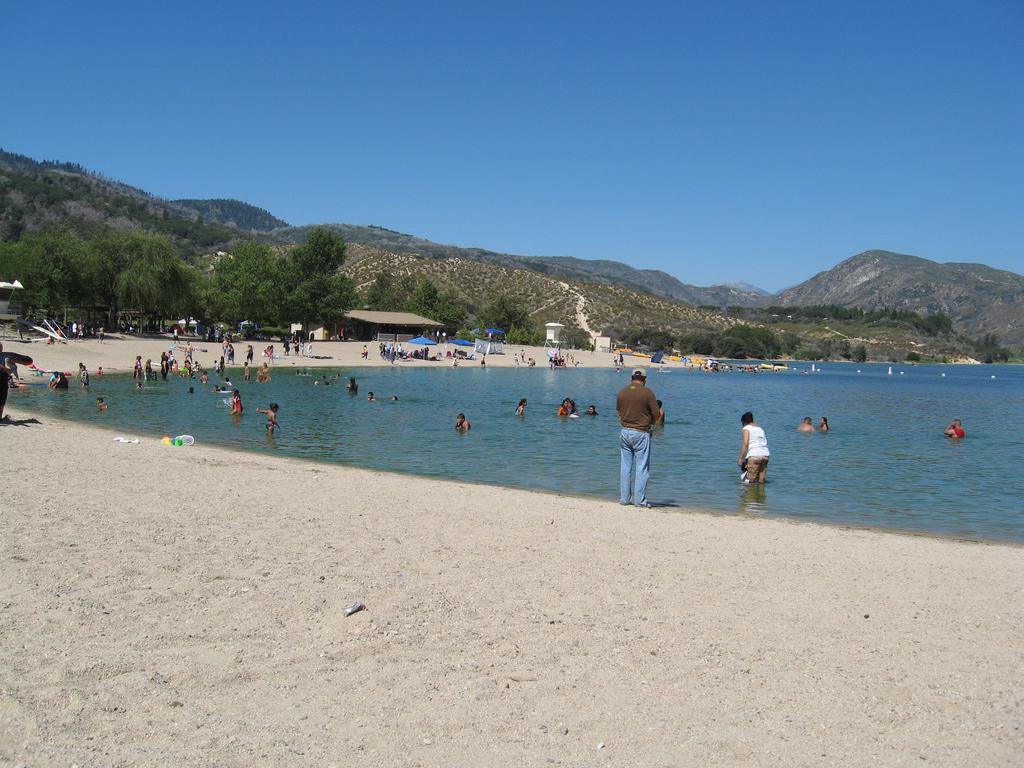Can you describe this image briefly? In the picture I can see people among them some are standing on the ground and some are in the water. In the background I can see trees, mountains, the sky and some other objects on the ground. 